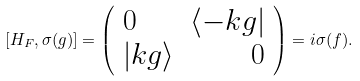<formula> <loc_0><loc_0><loc_500><loc_500>[ H _ { F } , \sigma ( g ) ] = \left ( \begin{array} { l r } 0 & \langle - k g | \\ | k g \rangle & 0 \end{array} \right ) = i \sigma ( f ) .</formula> 